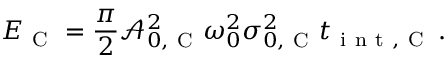Convert formula to latex. <formula><loc_0><loc_0><loc_500><loc_500>E _ { C } = \frac { \pi } { 2 } \mathcal { A } _ { 0 , C } ^ { 2 } \omega _ { 0 } ^ { 2 } \sigma _ { 0 , C } ^ { 2 } t _ { i n t , C } \, .</formula> 